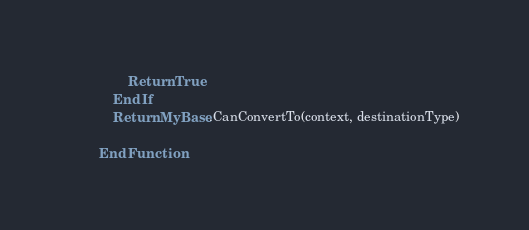<code> <loc_0><loc_0><loc_500><loc_500><_VisualBasic_>                Return True
            End If
            Return MyBase.CanConvertTo(context, destinationType)

        End Function
</code> 